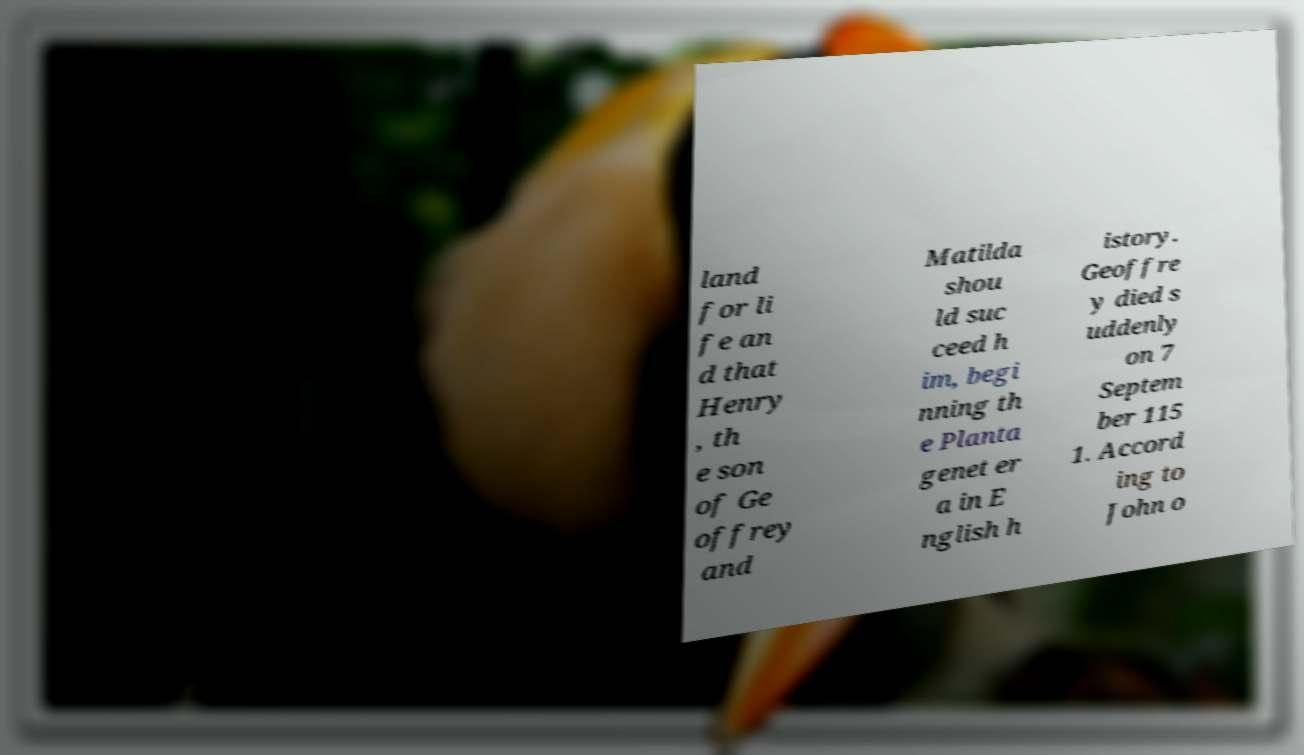There's text embedded in this image that I need extracted. Can you transcribe it verbatim? land for li fe an d that Henry , th e son of Ge offrey and Matilda shou ld suc ceed h im, begi nning th e Planta genet er a in E nglish h istory. Geoffre y died s uddenly on 7 Septem ber 115 1. Accord ing to John o 